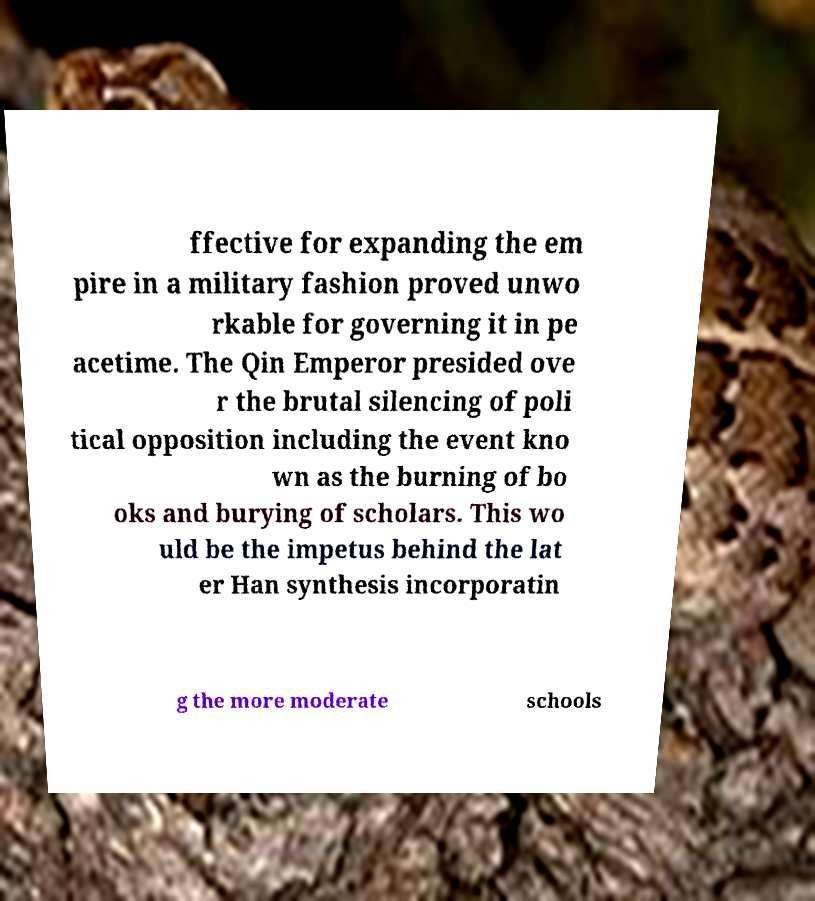Can you read and provide the text displayed in the image?This photo seems to have some interesting text. Can you extract and type it out for me? ffective for expanding the em pire in a military fashion proved unwo rkable for governing it in pe acetime. The Qin Emperor presided ove r the brutal silencing of poli tical opposition including the event kno wn as the burning of bo oks and burying of scholars. This wo uld be the impetus behind the lat er Han synthesis incorporatin g the more moderate schools 